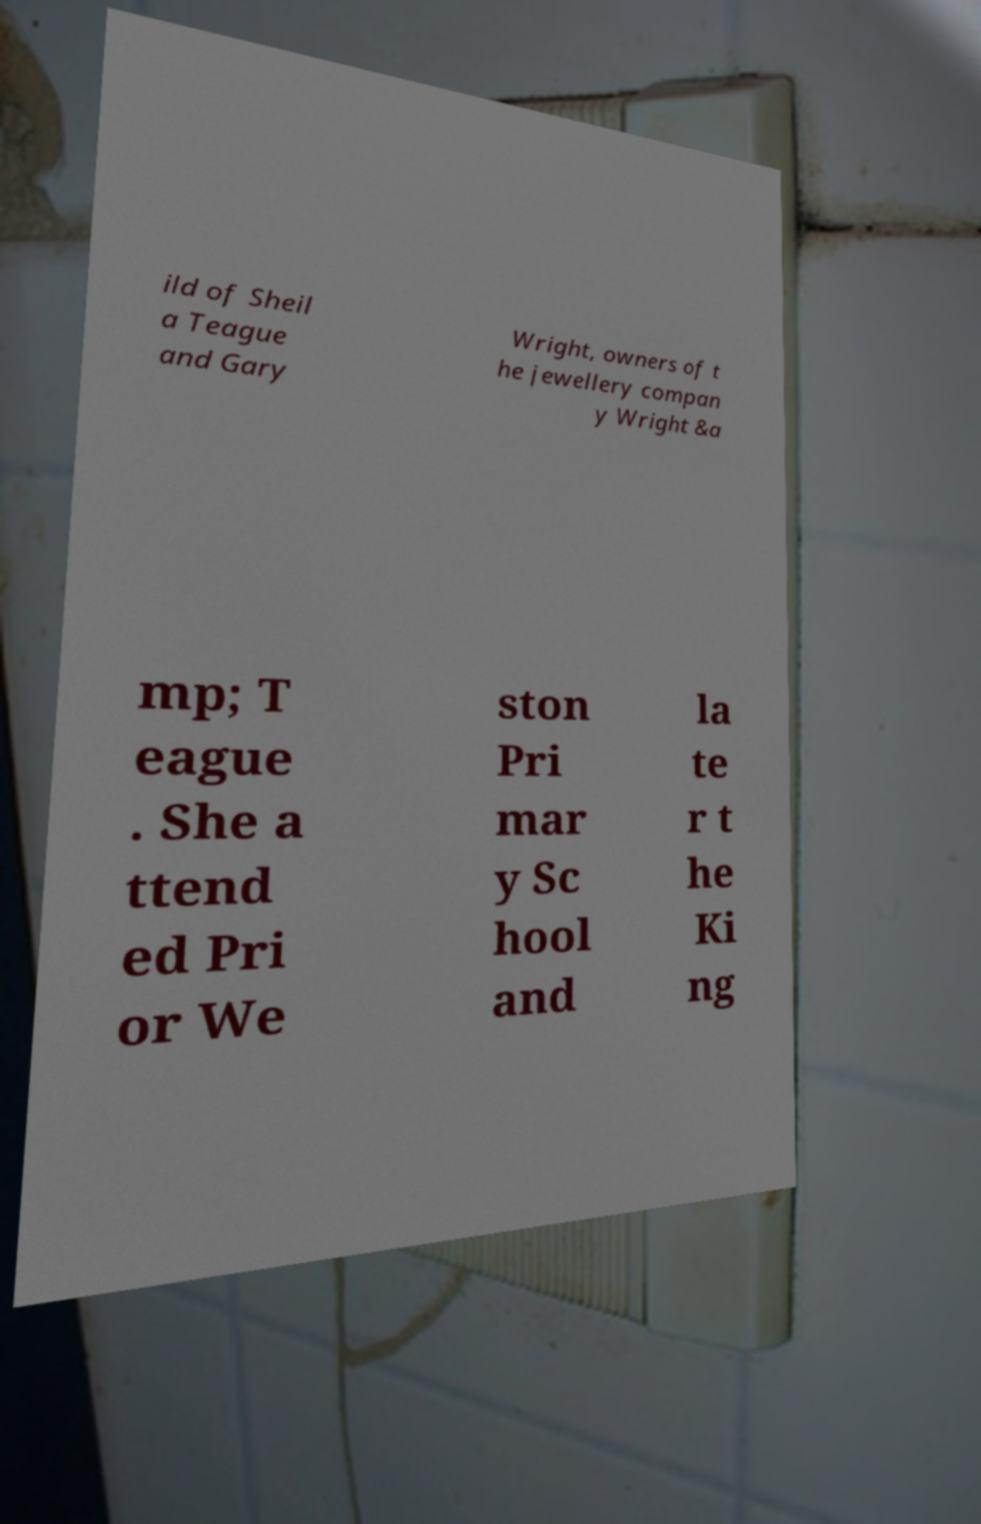Could you extract and type out the text from this image? ild of Sheil a Teague and Gary Wright, owners of t he jewellery compan y Wright &a mp; T eague . She a ttend ed Pri or We ston Pri mar y Sc hool and la te r t he Ki ng 